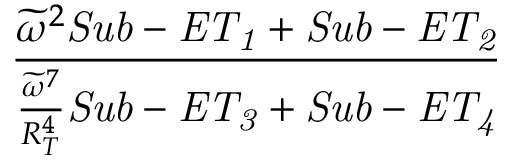Convert formula to latex. <formula><loc_0><loc_0><loc_500><loc_500>\frac { \widetilde { \omega } ^ { 2 } S u b - E T _ { 1 } + S u b - E T _ { 2 } } { \frac { \widetilde { \omega } ^ { 7 } } { R _ { T } ^ { 4 } } S u b - E T _ { 3 } + S u b - E T _ { 4 } }</formula> 